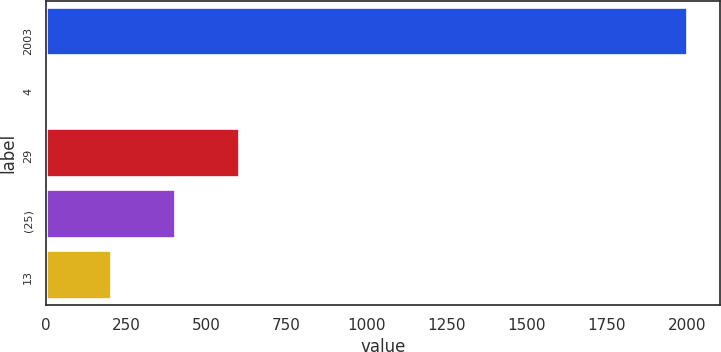<chart> <loc_0><loc_0><loc_500><loc_500><bar_chart><fcel>2003<fcel>4<fcel>29<fcel>(25)<fcel>13<nl><fcel>2002<fcel>3<fcel>602.7<fcel>402.8<fcel>202.9<nl></chart> 